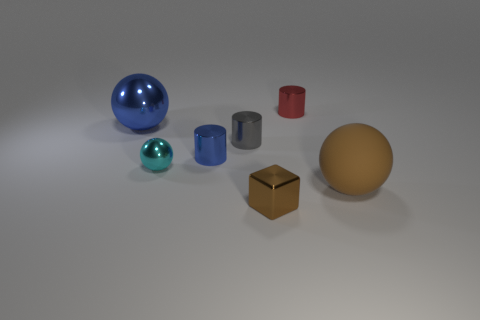Add 3 yellow rubber cubes. How many objects exist? 10 Subtract all cubes. How many objects are left? 6 Add 4 small brown blocks. How many small brown blocks are left? 5 Add 4 large yellow rubber balls. How many large yellow rubber balls exist? 4 Subtract 1 gray cylinders. How many objects are left? 6 Subtract all small blue shiny objects. Subtract all small gray rubber cylinders. How many objects are left? 6 